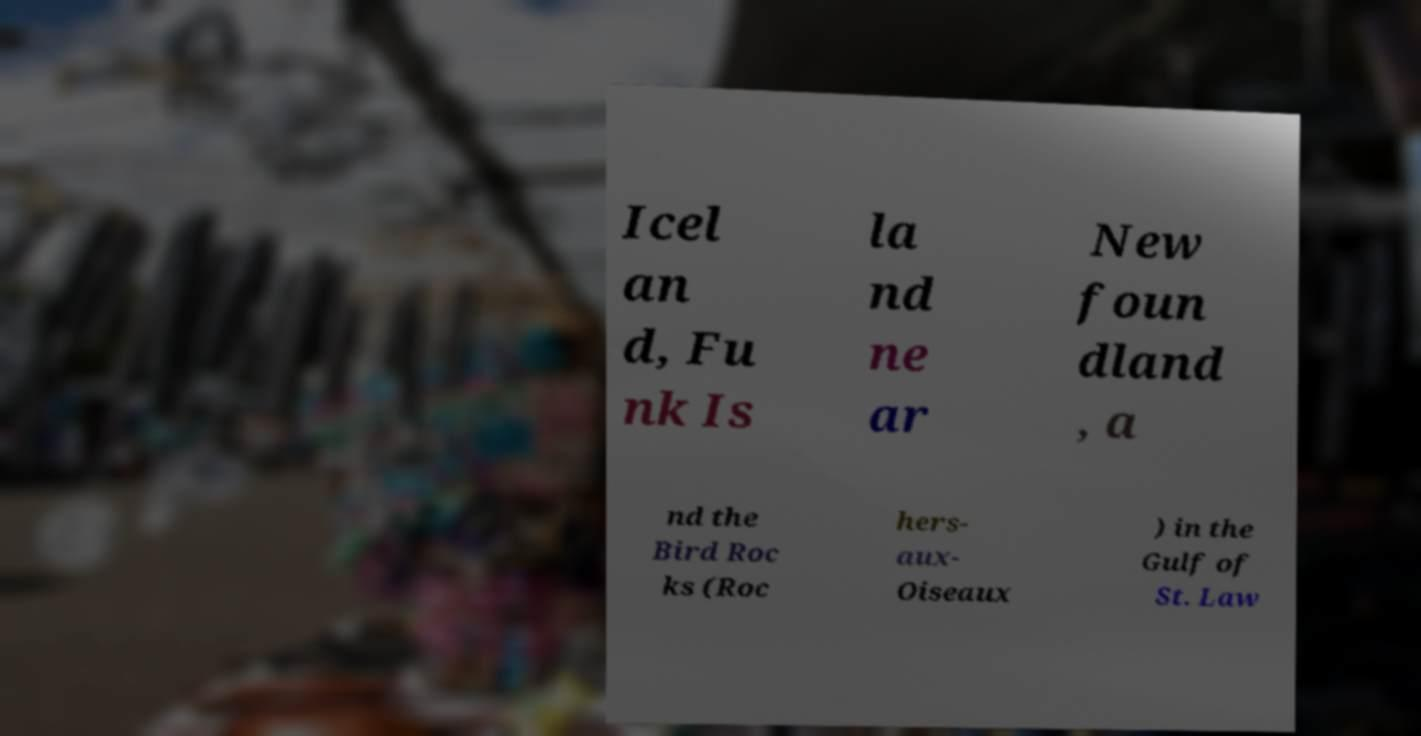Could you assist in decoding the text presented in this image and type it out clearly? Icel an d, Fu nk Is la nd ne ar New foun dland , a nd the Bird Roc ks (Roc hers- aux- Oiseaux ) in the Gulf of St. Law 